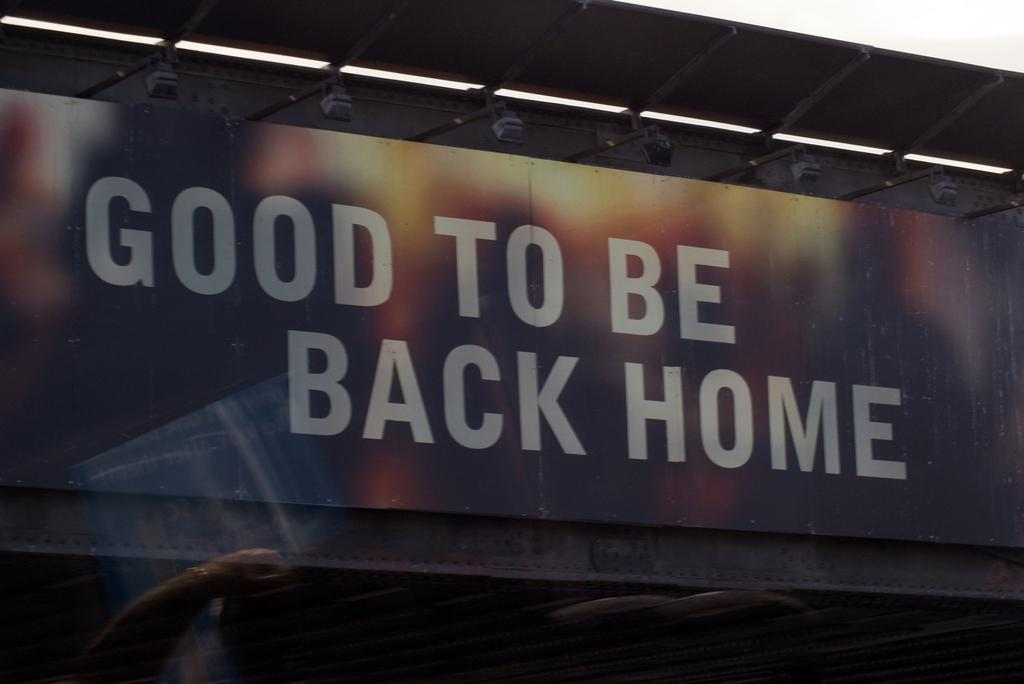<image>
Describe the image concisely. A large sign on a wall that reads "Good to be back home". 